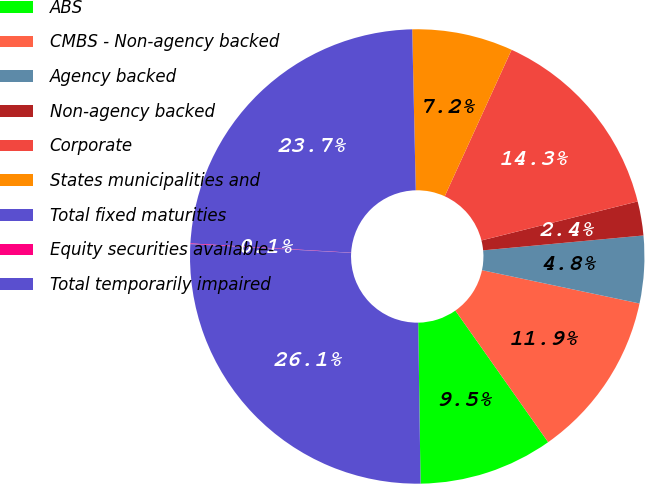Convert chart to OTSL. <chart><loc_0><loc_0><loc_500><loc_500><pie_chart><fcel>ABS<fcel>CMBS - Non-agency backed<fcel>Agency backed<fcel>Non-agency backed<fcel>Corporate<fcel>States municipalities and<fcel>Total fixed maturities<fcel>Equity securities available-<fcel>Total temporarily impaired<nl><fcel>9.54%<fcel>11.91%<fcel>4.79%<fcel>2.42%<fcel>14.29%<fcel>7.17%<fcel>23.73%<fcel>0.05%<fcel>26.1%<nl></chart> 